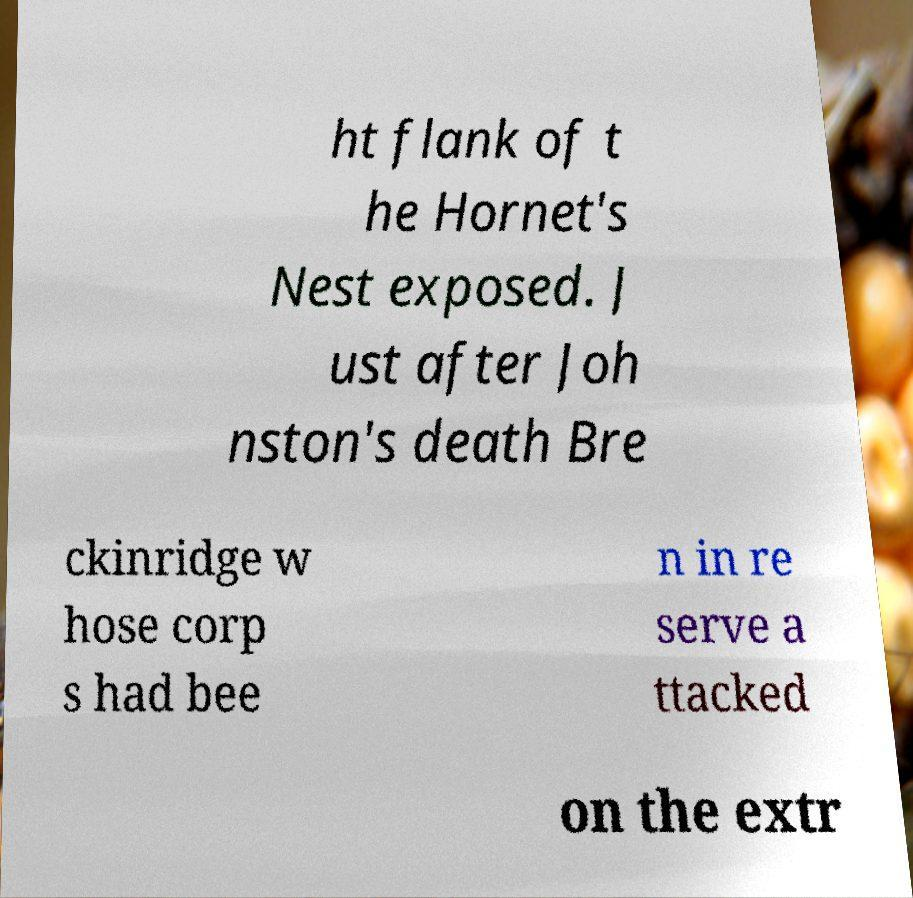For documentation purposes, I need the text within this image transcribed. Could you provide that? ht flank of t he Hornet's Nest exposed. J ust after Joh nston's death Bre ckinridge w hose corp s had bee n in re serve a ttacked on the extr 